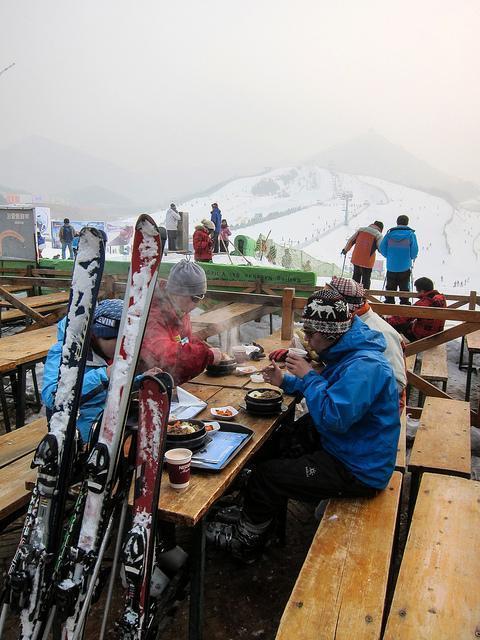How many benches can be seen?
Give a very brief answer. 4. How many dining tables are in the picture?
Give a very brief answer. 3. How many ski are there?
Give a very brief answer. 2. How many people are in the picture?
Give a very brief answer. 7. 